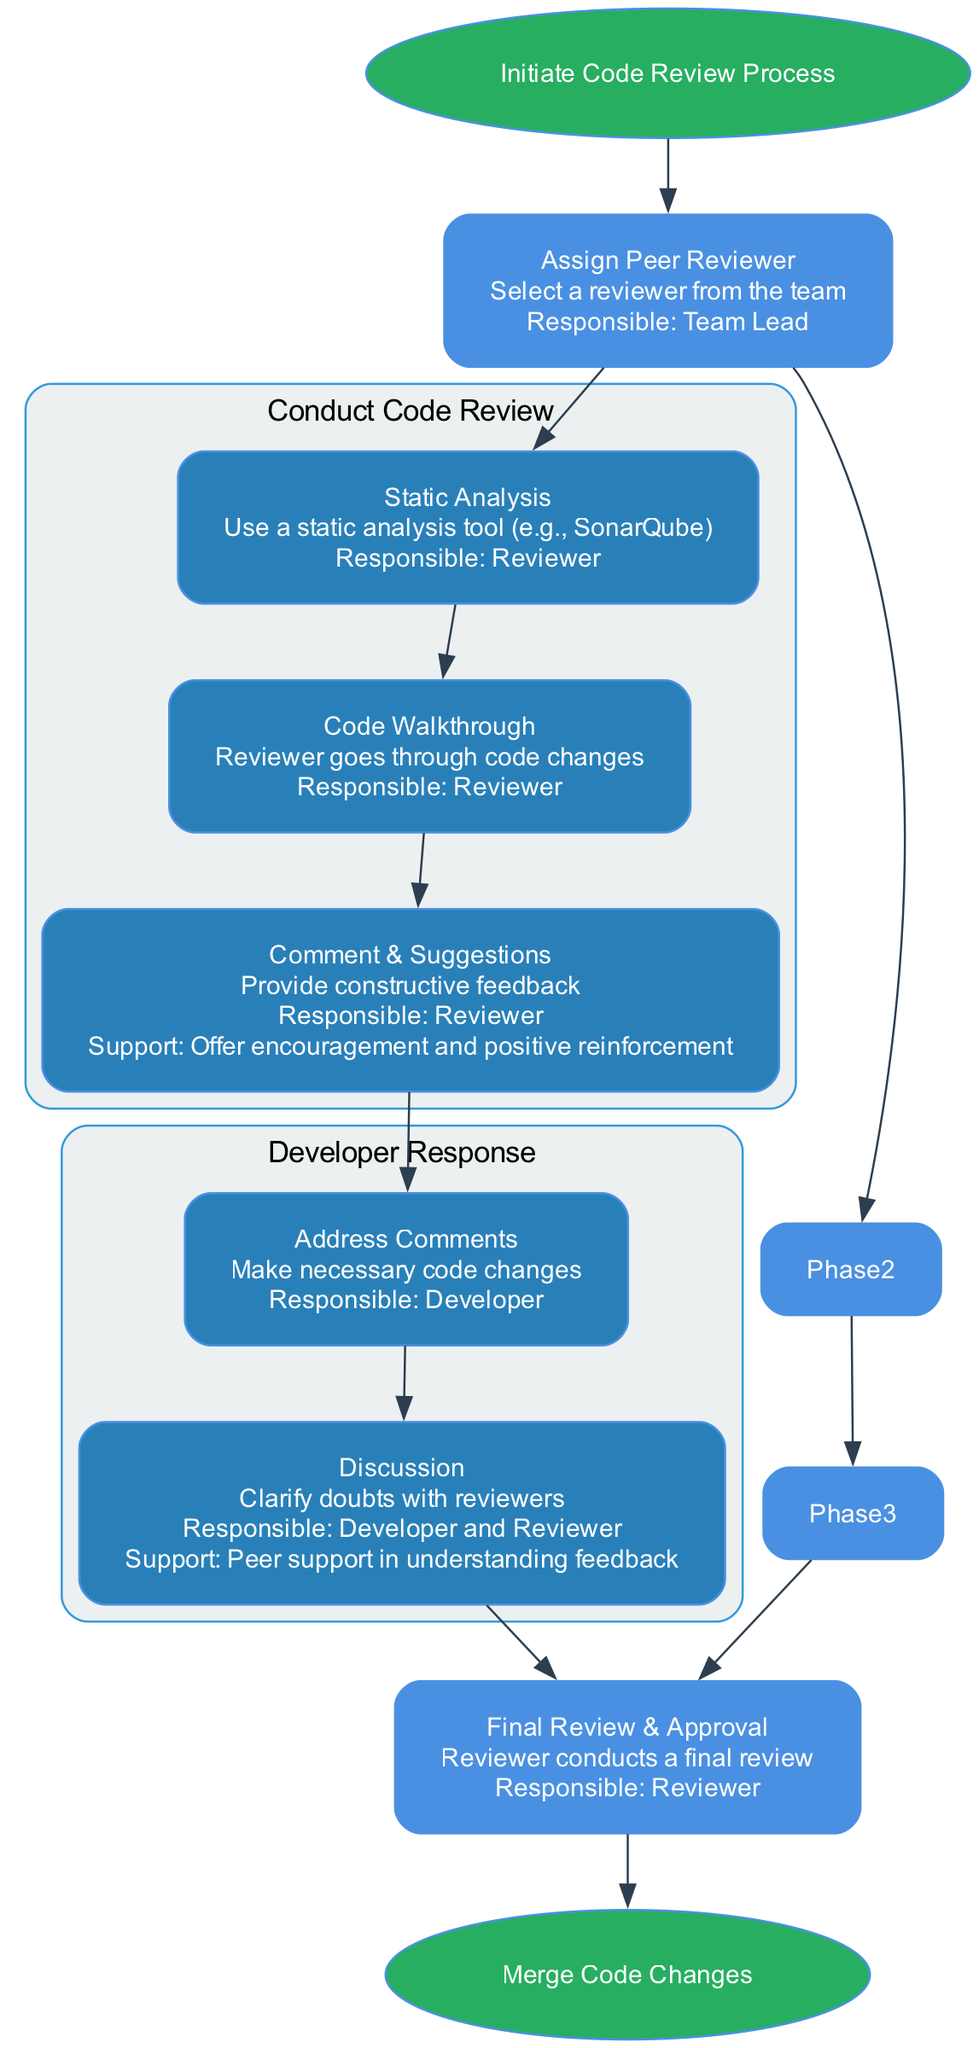What action starts the clinical pathway? The diagram indicates that the starting action in the clinical pathway is to "Submit a pull request." This is outlined in the first node labeled 'Start.'
Answer: Submit a pull request Who is responsible for assigning a peer reviewer? According to the diagram, the Team Lead is responsible for assigning a peer reviewer as specified in Phase 1.
Answer: Team Lead What occurs during the "Code Walkthrough" subphase? In the diagram, the 'Code Walkthrough' subphase entails the action "Reviewer goes through code changes," indicating an interactive review process.
Answer: Reviewer goes through code changes How many subphases are there in Phase 2? The diagram shows that there are three subphases detailed under Phase 2, leading to a total of three elements in that section.
Answer: 3 What is the support offered during the "Discussion" subphase in Phase 3? The diagram states that during the "Discussion" subphase, peer support is provided to help the developer understand feedback received from reviewers.
Answer: Peer support in understanding feedback What is the final action taken in the clinical pathway? The end node of the diagram specifies that the final action is to "Integrate changes into the main branch," completing the code review process.
Answer: Integrate changes into the main branch In which phase does the developer address comments? The diagram shows that addressing comments is part of the "Developer Response" phase, specifically under one of the subphases titled "Address Comments."
Answer: Developer Response What is the purpose of conducting a "Final Review"? The diagram outlines that the 'Final Review' serves to ensure that all changes have been appropriately reviewed before they are merged, confirming the quality of the code.
Answer: Confirm quality of the code 